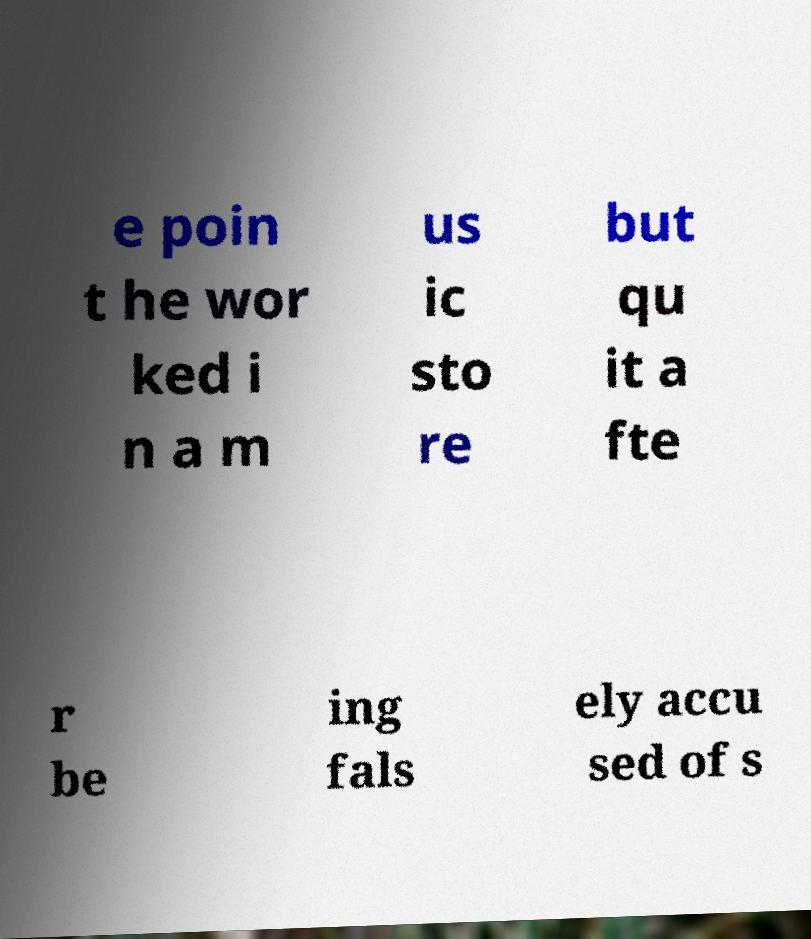Please identify and transcribe the text found in this image. e poin t he wor ked i n a m us ic sto re but qu it a fte r be ing fals ely accu sed of s 